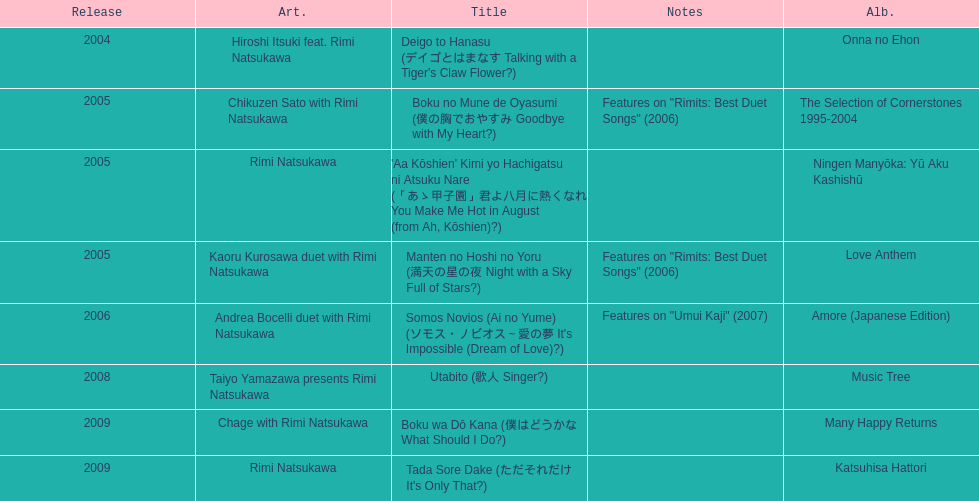Which was released earlier, deigo to hanasu or utabito? Deigo to Hanasu. 